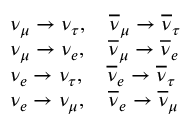<formula> <loc_0><loc_0><loc_500><loc_500>\begin{array} { r l } & { \nu _ { \mu } \rightarrow \nu _ { \tau } , \overline { \nu } _ { \mu } \rightarrow \overline { \nu } _ { \tau } } \\ & { \nu _ { \mu } \rightarrow \nu _ { e } , \overline { \nu } _ { \mu } \rightarrow \overline { \nu } _ { e } } \\ & { \nu _ { e } \rightarrow \nu _ { \tau } , \overline { \nu } _ { e } \rightarrow \overline { \nu } _ { \tau } } \\ & { \nu _ { e } \rightarrow \nu _ { \mu } , \overline { \nu } _ { e } \rightarrow \overline { \nu } _ { \mu } } \end{array}</formula> 